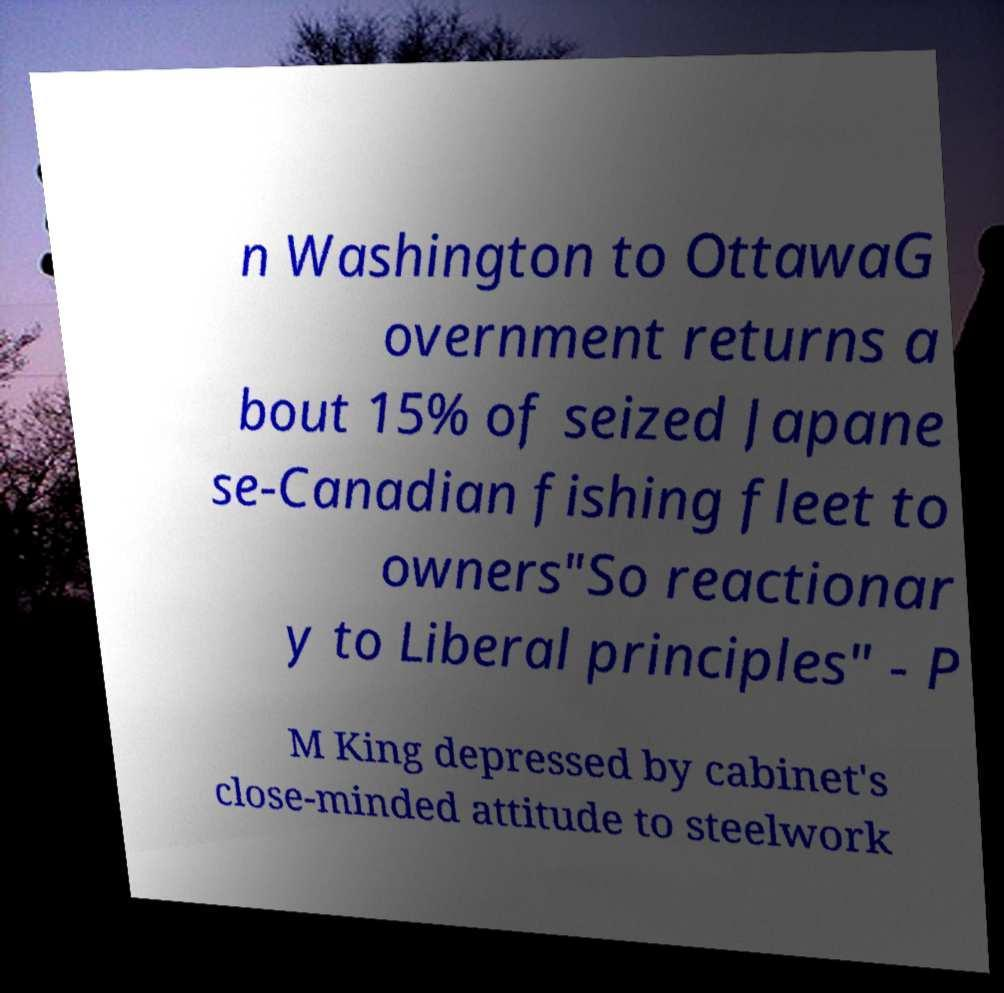Please read and relay the text visible in this image. What does it say? n Washington to OttawaG overnment returns a bout 15% of seized Japane se-Canadian fishing fleet to owners"So reactionar y to Liberal principles" - P M King depressed by cabinet's close-minded attitude to steelwork 